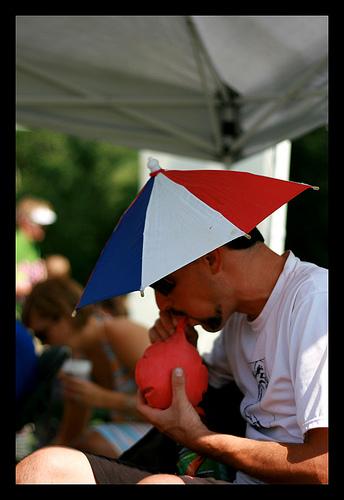What is the man wearing on his head?
Keep it brief. Umbrella. Is there a flag on the man's shirt?
Keep it brief. No. What is the man blowing up?
Answer briefly. Balloon. Is it cold in this picture?
Be succinct. No. 